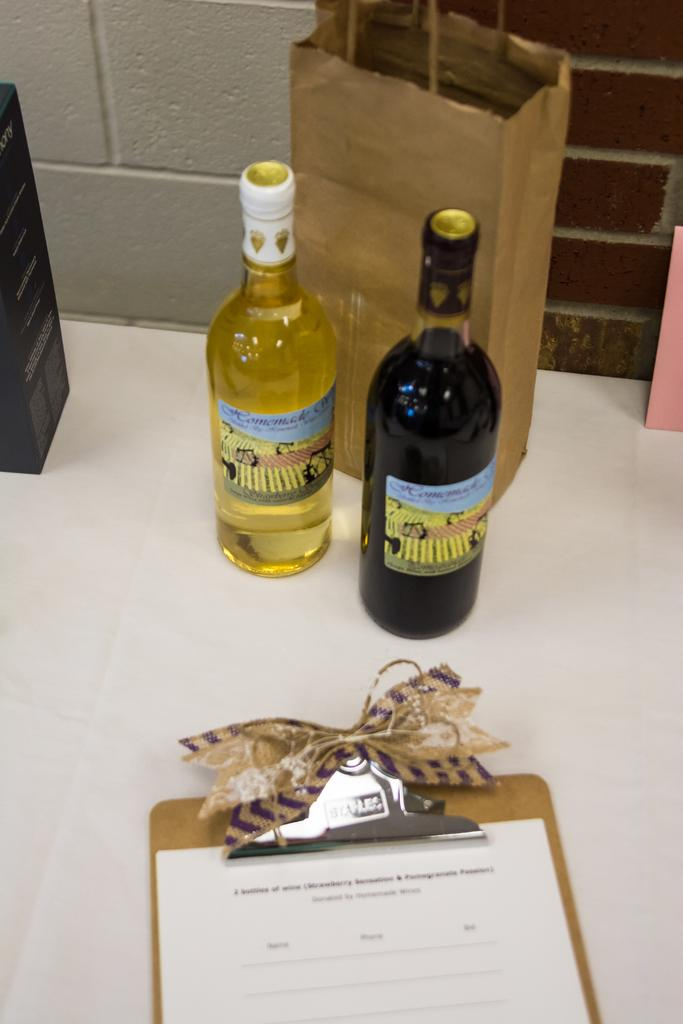What is the setting of the image? The image is inside a room. What objects can be seen in the image? There are two bottles, an examination pad, and a paper in the image. What can be seen in the background of the image? There is a wall and a cotton bag in the background of the image. How many girls are present in the image? There is no girl present in the image. What type of flowers can be seen in the image? There are no flowers visible in the image. 